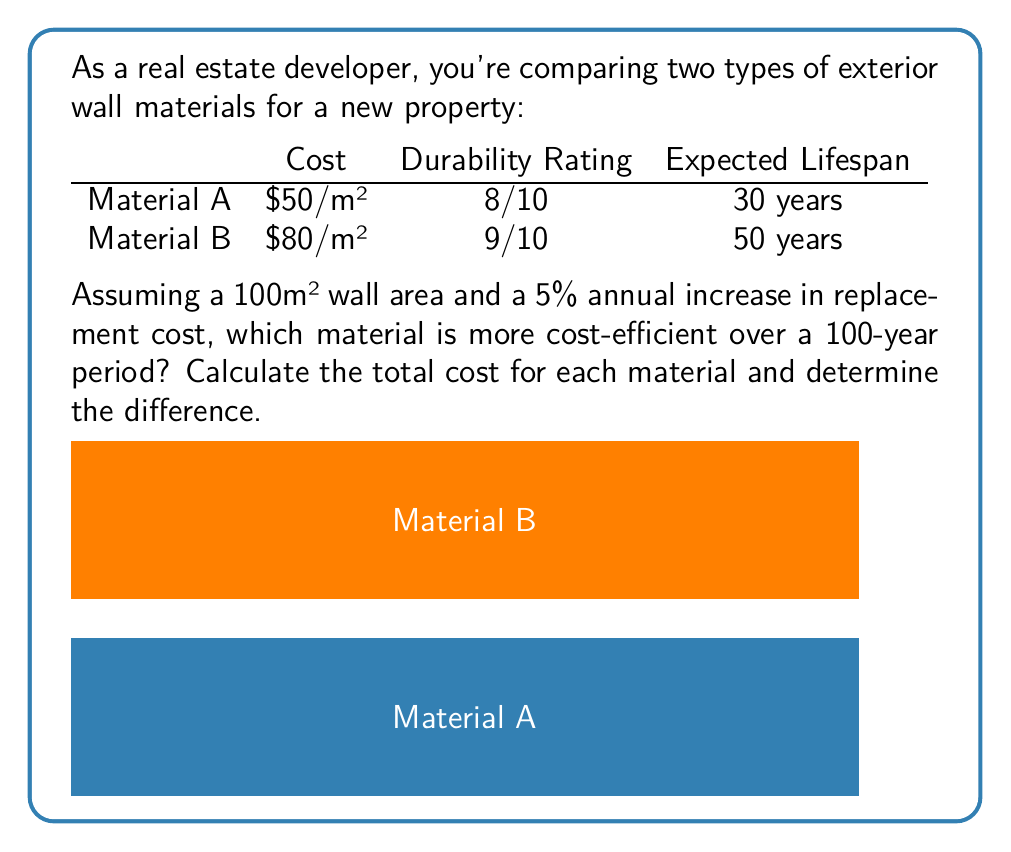Can you answer this question? Let's approach this step-by-step:

1) First, calculate the initial cost for each material:
   Material A: $50/m² × 100m² = $5,000
   Material B: $80/m² × 100m² = $8,000

2) Calculate how many times each material needs to be replaced in 100 years:
   Material A: 100 years ÷ 30 years = 3.33 (rounded up to 4 replacements)
   Material B: 100 years ÷ 50 years = 2 replacements

3) Calculate the cost of each replacement, considering the 5% annual increase:
   For Material A:
   - 2nd replacement (after 30 years): $5,000 × (1.05)^30 = $21,609.71
   - 3rd replacement (after 60 years): $5,000 × (1.05)^60 = $93,396.45
   - 4th replacement (after 90 years): $5,000 × (1.05)^90 = $403,687.06

   For Material B:
   - 2nd replacement (after 50 years): $8,000 × (1.05)^50 = $57,433.91

4) Sum up the total costs:
   Material A: $5,000 + $21,609.71 + $93,396.45 + $403,687.06 = $523,693.22
   Material B: $8,000 + $57,433.91 = $65,433.91

5) Calculate the difference:
   $523,693.22 - $65,433.91 = $458,259.31

Therefore, Material B is more cost-efficient over the 100-year period, saving $458,259.31 compared to Material A.
Answer: Material B; $458,259.31 saved 